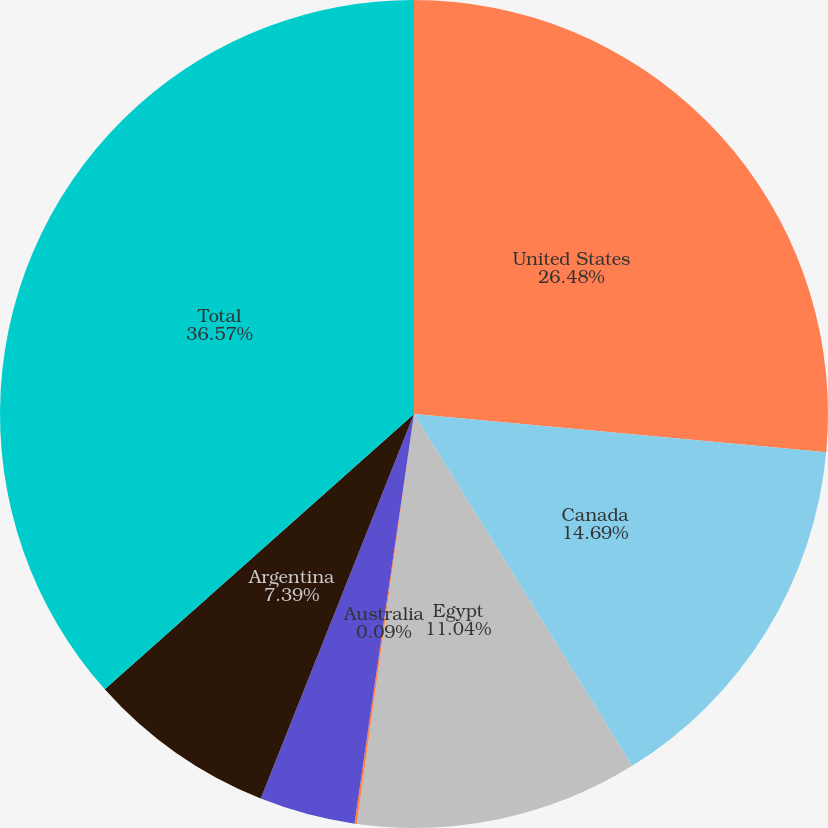<chart> <loc_0><loc_0><loc_500><loc_500><pie_chart><fcel>United States<fcel>Canada<fcel>Egypt<fcel>Australia<fcel>North Sea<fcel>Argentina<fcel>Total<nl><fcel>26.48%<fcel>14.69%<fcel>11.04%<fcel>0.09%<fcel>3.74%<fcel>7.39%<fcel>36.58%<nl></chart> 